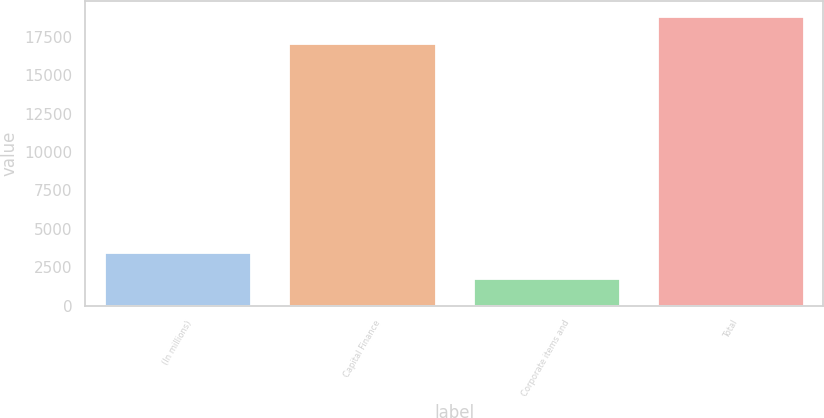Convert chart to OTSL. <chart><loc_0><loc_0><loc_500><loc_500><bar_chart><fcel>(In millions)<fcel>Capital Finance<fcel>Corporate items and<fcel>Total<nl><fcel>3507.9<fcel>17079<fcel>1800<fcel>18879<nl></chart> 